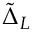<formula> <loc_0><loc_0><loc_500><loc_500>\tilde { \Delta } _ { L }</formula> 